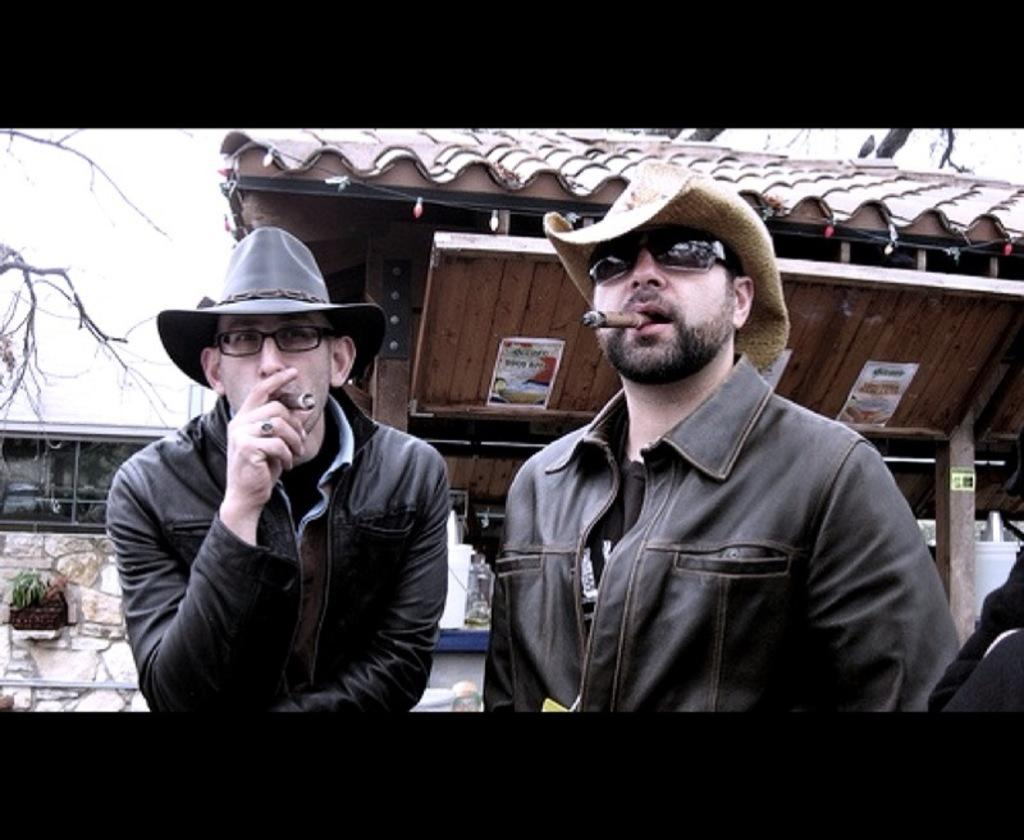How many people are in the image? There are two persons in the image. What are the two persons holding? The two persons are holding a cigar. What can be seen in the background of the image? There is a shed, a wall, and a tree in the background of the image. Where is the sofa located in the image? There is no sofa present in the image. What book is the person reading in the image? There is no book or person reading in the image. 